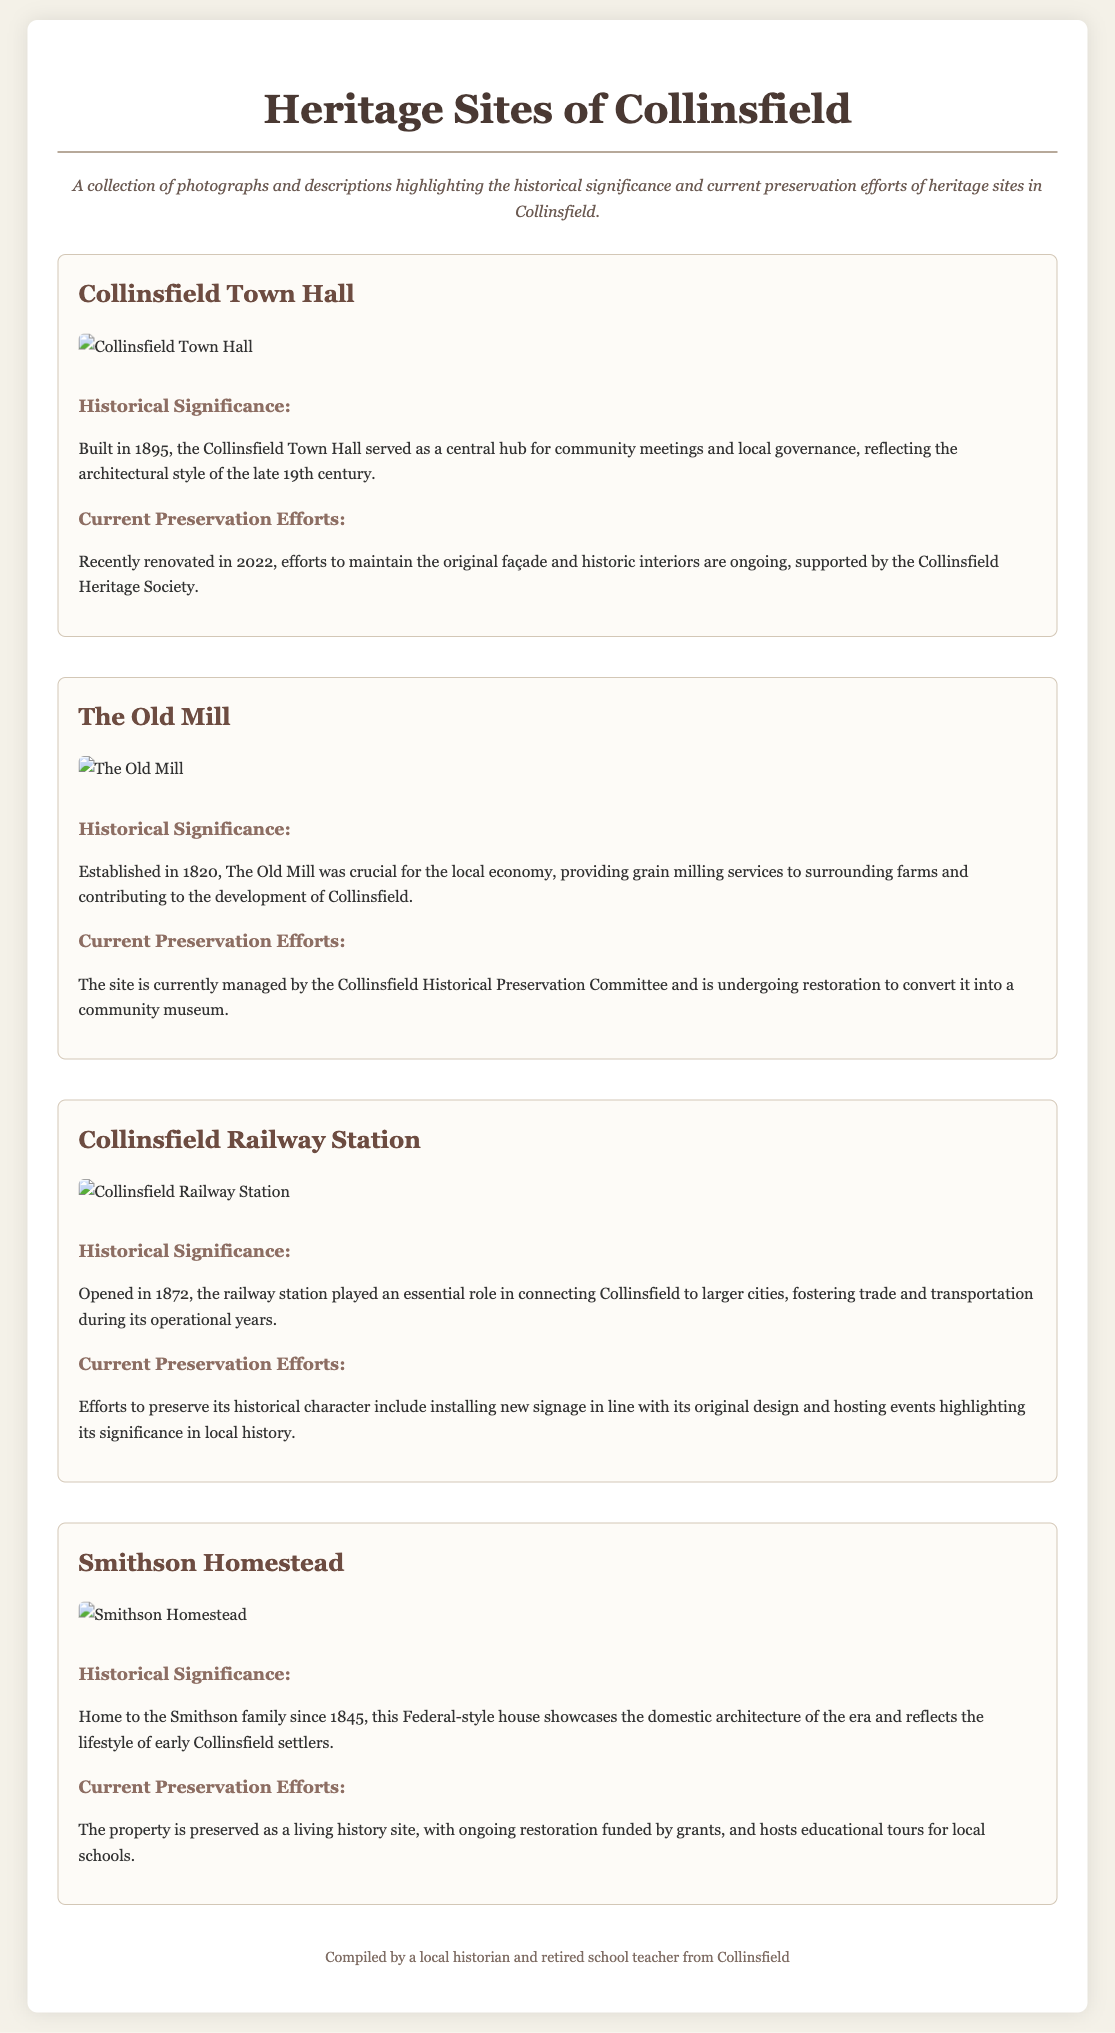What year was Collinsfield Town Hall built? The document states that Collinsfield Town Hall was built in 1895.
Answer: 1895 What is the historical significance of The Old Mill? The document mentions that The Old Mill was crucial for the local economy, providing grain milling services.
Answer: Crucial for the local economy Who manages the preservation of Collinsfield Railway Station? The document indicates that preservation efforts include installing new signage and hosting events, but does not specify a managing body.
Answer: Not specified What kind of style does the Smithson Homestead represent? The document describes the Smithson Homestead as showcasing Federal-style architecture.
Answer: Federal-style In what year did the railway station open? According to the document, the Collinsfield Railway Station was opened in 1872.
Answer: 1872 What organization supports preservation efforts for the Collinsfield Town Hall? The document states that preservation efforts are supported by the Collinsfield Heritage Society.
Answer: Collinsfield Heritage Society What current effort is being made to The Old Mill? The document notes that The Old Mill is undergoing restoration to convert it into a community museum.
Answer: Restoration to convert it into a community museum How long has the Smithson family been associated with the homestead? The document indicates that the Smithson family has been associated with the homestead since 1845.
Answer: Since 1845 